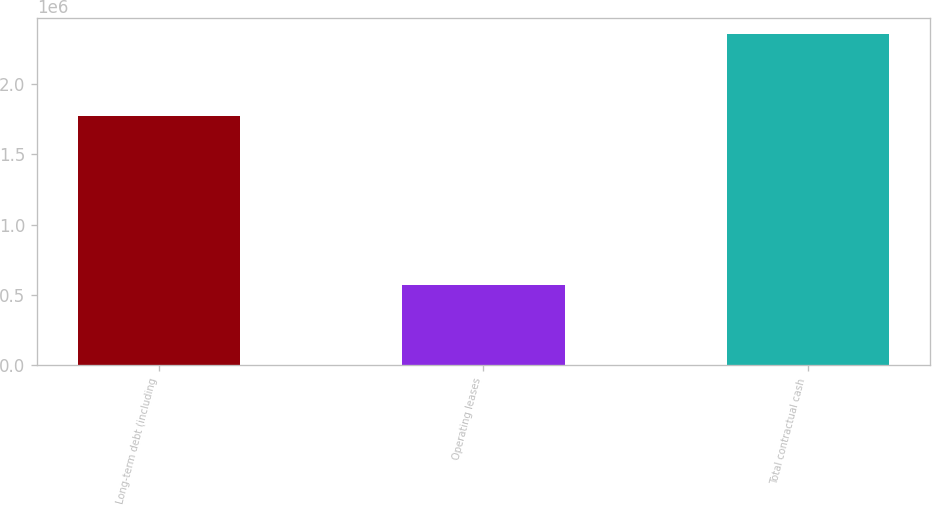Convert chart to OTSL. <chart><loc_0><loc_0><loc_500><loc_500><bar_chart><fcel>Long-term debt (including<fcel>Operating leases<fcel>Total contractual cash<nl><fcel>1.7692e+06<fcel>573311<fcel>2.35521e+06<nl></chart> 